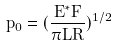<formula> <loc_0><loc_0><loc_500><loc_500>p _ { 0 } = ( \frac { E ^ { * } F } { \pi L R } ) ^ { 1 / 2 }</formula> 